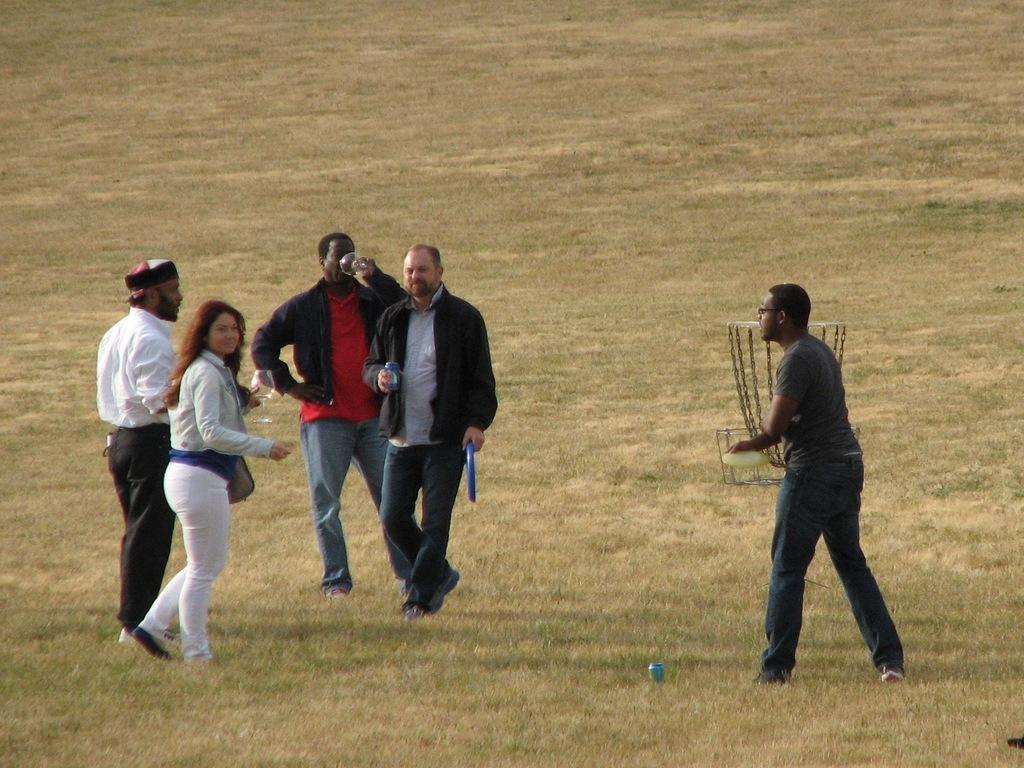Could you give a brief overview of what you see in this image? In the image in the center, we can see a few people are standing and holding some objects. In the background we can see the grass. 